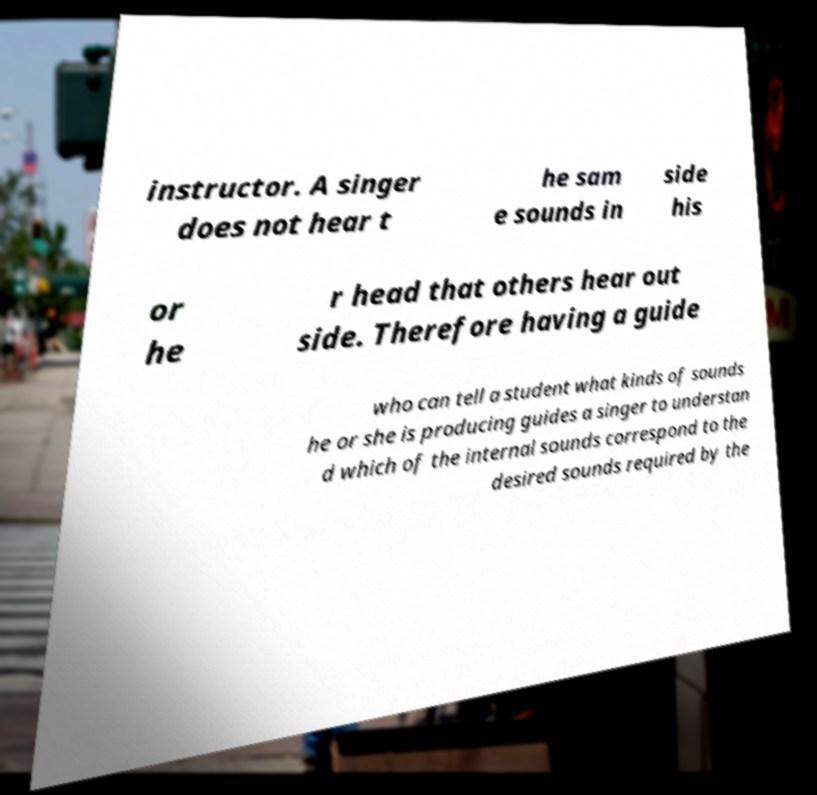Can you accurately transcribe the text from the provided image for me? instructor. A singer does not hear t he sam e sounds in side his or he r head that others hear out side. Therefore having a guide who can tell a student what kinds of sounds he or she is producing guides a singer to understan d which of the internal sounds correspond to the desired sounds required by the 